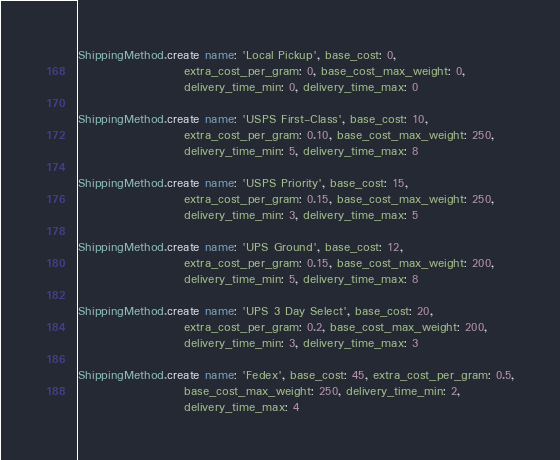<code> <loc_0><loc_0><loc_500><loc_500><_Ruby_>ShippingMethod.create name: 'Local Pickup', base_cost: 0,
                      extra_cost_per_gram: 0, base_cost_max_weight: 0,
                      delivery_time_min: 0, delivery_time_max: 0

ShippingMethod.create name: 'USPS First-Class', base_cost: 10,
                      extra_cost_per_gram: 0.10, base_cost_max_weight: 250,
                      delivery_time_min: 5, delivery_time_max: 8

ShippingMethod.create name: 'USPS Priority', base_cost: 15,
                      extra_cost_per_gram: 0.15, base_cost_max_weight: 250,
                      delivery_time_min: 3, delivery_time_max: 5

ShippingMethod.create name: 'UPS Ground', base_cost: 12,
                      extra_cost_per_gram: 0.15, base_cost_max_weight: 200,
                      delivery_time_min: 5, delivery_time_max: 8

ShippingMethod.create name: 'UPS 3 Day Select', base_cost: 20,
                      extra_cost_per_gram: 0.2, base_cost_max_weight: 200,
                      delivery_time_min: 3, delivery_time_max: 3

ShippingMethod.create name: 'Fedex', base_cost: 45, extra_cost_per_gram: 0.5,
                      base_cost_max_weight: 250, delivery_time_min: 2,
                      delivery_time_max: 4
</code> 